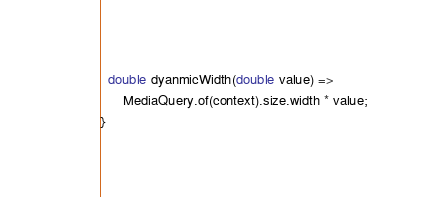Convert code to text. <code><loc_0><loc_0><loc_500><loc_500><_Dart_>  double dyanmicWidth(double value) =>
      MediaQuery.of(context).size.width * value;
}
</code> 